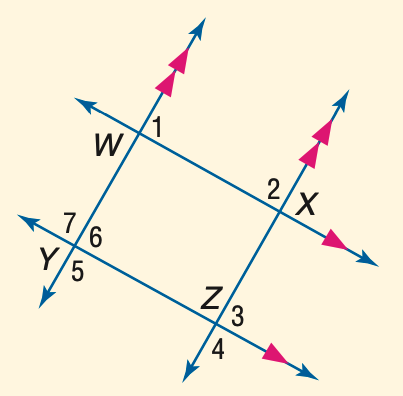Answer the mathemtical geometry problem and directly provide the correct option letter.
Question: In the figure, m \angle 1 = 53. Find the measure of \angle 3.
Choices: A: 53 B: 57 C: 63 D: 67 A 